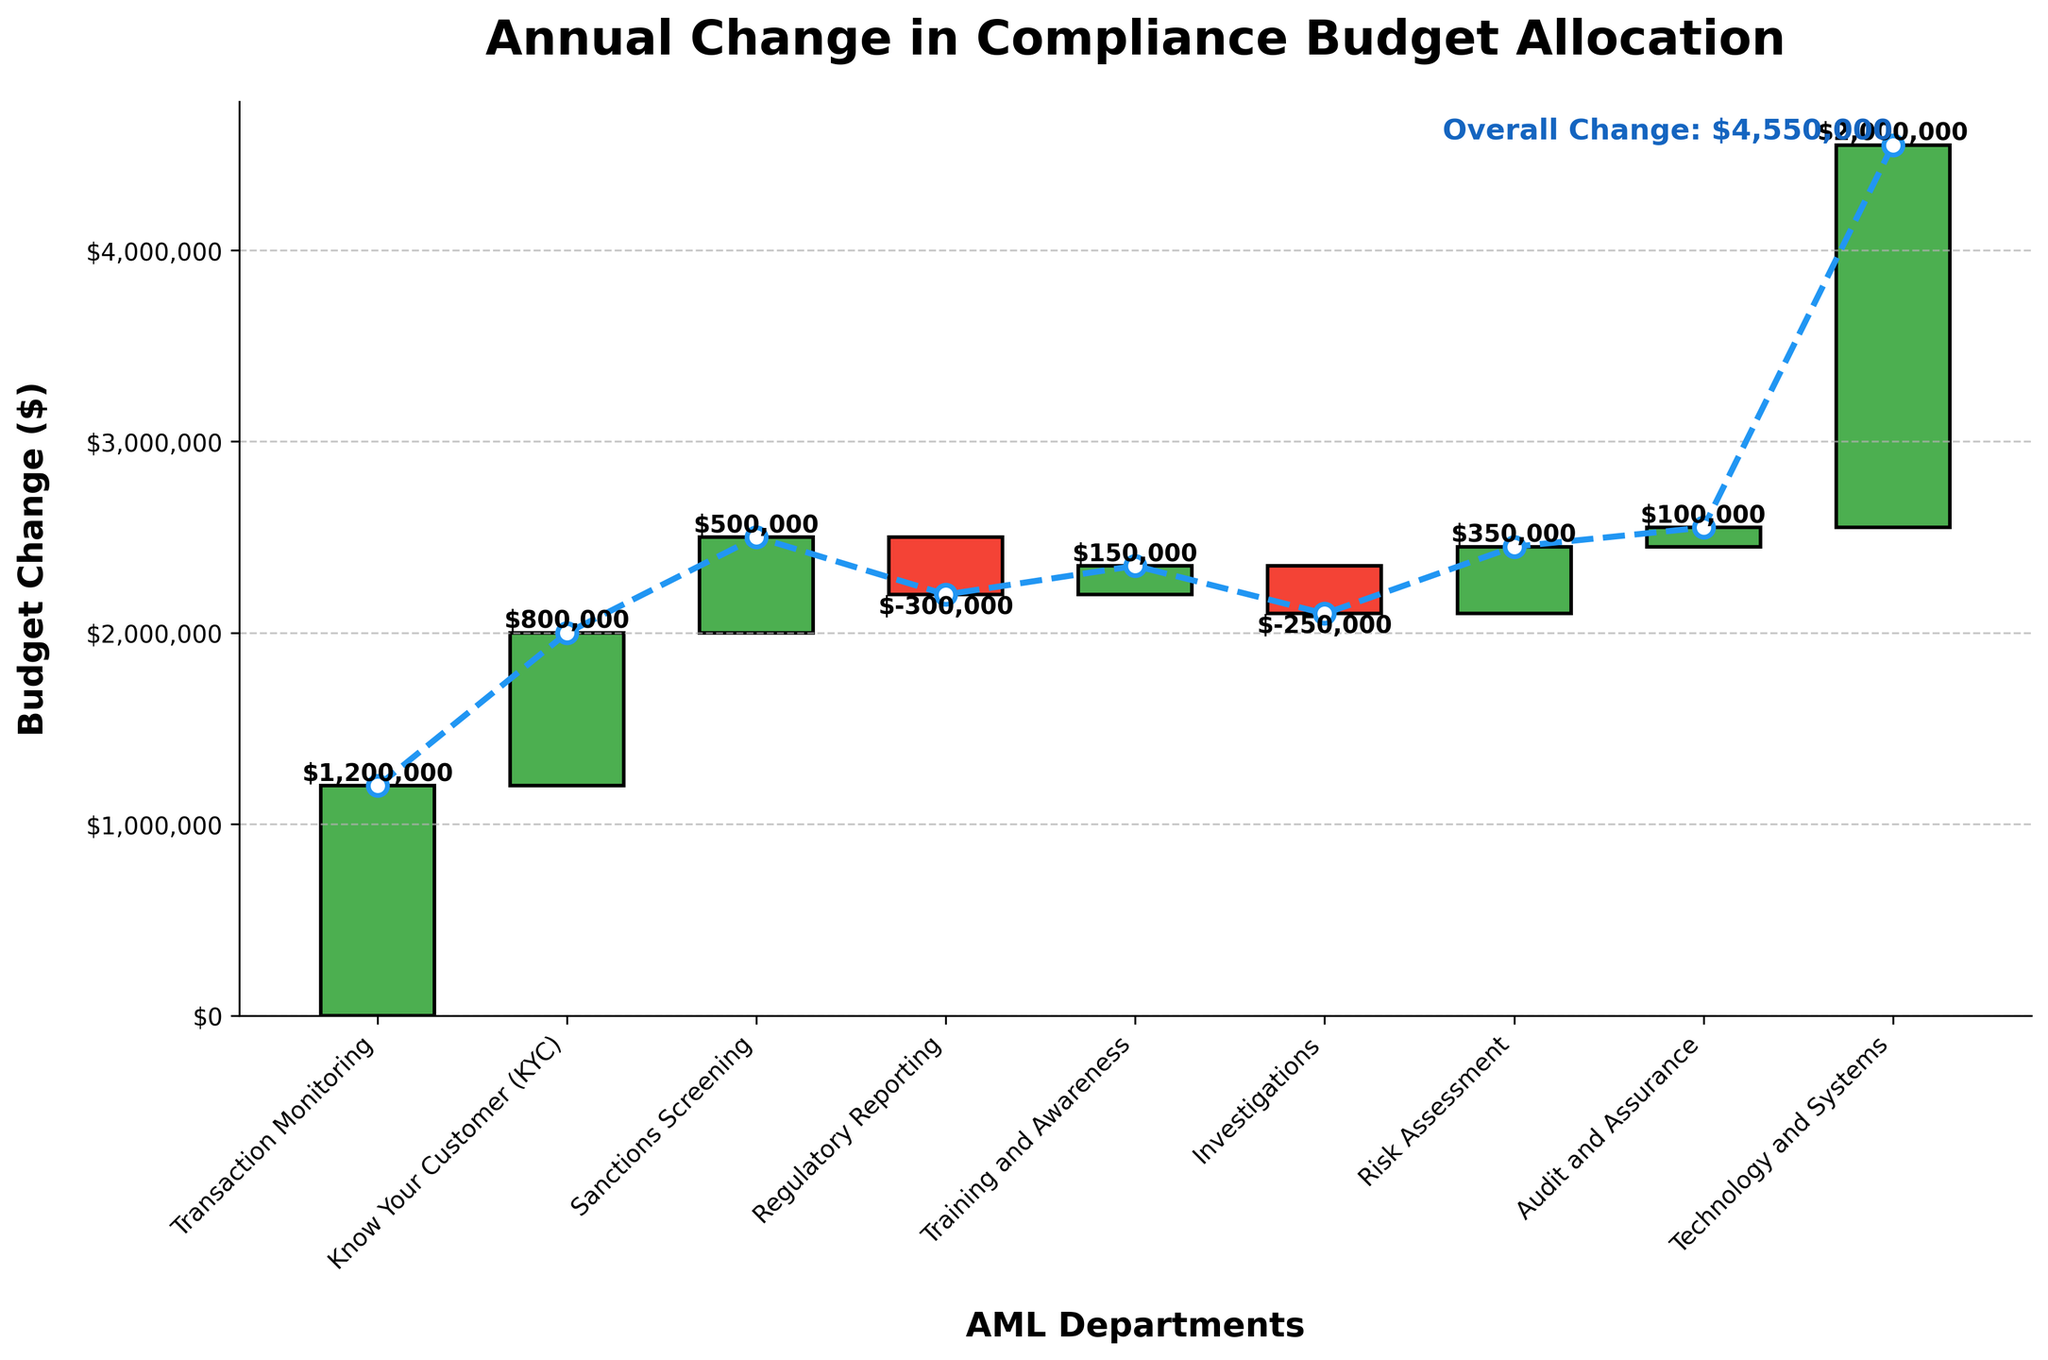How much was the overall change in the budget? The overall change is provided at the end of the chart, highlighted in blue text. The text indicates "Overall Change: $4,550,000."
Answer: $4,550,000 Which department had the highest increase in budget allocation? By looking at the bars, the department with the tallest green bar has the highest increase. The "Technology and Systems" department has the highest increase of $2,000,000.
Answer: Technology and Systems Which department had the largest decrease in budget allocation? The department with the longest red bar indicates the largest decrease. The "Regulatory Reporting" department has the largest decrease of $300,000.
Answer: Regulatory Reporting How much did the "Transaction Monitoring" department's budget change? The "Transaction Monitoring" department's bar shows a budget change of $1,200,000, indicated by the green bar and the text label on top of the bar.
Answer: $1,200,000 Which departments have a negative budget change? Negative budget changes are indicated by the red bars. The departments "Regulatory Reporting" and "Investigations" have a negative budget change.
Answer: Regulatory Reporting and Investigations What is the cumulative budget change just before the "Audit and Assurance" department's bar? The bar before "Audit and Assurance" is "Risk Assessment." The cumulative budget change is the sum of previous changes up to this point. Referring to the bars: 
  1,200,000 (Transaction Monitoring) 
+ 800,000 (Know Your Customer)
+ 500,000 (Sanctions Screening)
- 300,000 (Regulatory Reporting)
+ 150,000 (Training and Awareness)
- 250,000 (Investigations)
+ 350,000 (Risk Assessment)
= $2,450,000.
The cumulative budget change before "Audit and Assurance" is $2,450,000.
Answer: $2,450,000 Which department lies midway in terms of changes between the highest increase and the largest decrease? To find the midpoint in changes, one needs to consider both the highest increase and the largest decrease and find a department whose change is halfway between the two values. The highest increase is "Technology and Systems" with $2,000,000 and the largest decrease is "Regulatory Reporting" with -$300,000. The midway point between these two values might be subjective based on other departments' values closely aligning between this range:
(2,000,000 to -300,000) => An approximate midpoint increase/decrease close to average. "Risk Assessment" department with a change of +$350,000 seems to act as a reasonable midpoint.
Answer: Risk Assessment What is the total combined change for all departments with a positive change? Add the changes of all departments with a positive change:
1,200,000 (Transaction Monitoring) 
+ 800,000 (Know Your Customer)
+ 500,000 (Sanctions Screening)
+ 150,000 (Training and Awareness)
+ 350,000 (Risk Assessment)
+ 100,000 (Audit and Assurance) 
+ 2,000,000 (Technology and Systems) 
= $5,100,000.
The total combined change for all departments with a positive change is $5,100,000.
Answer: $5,100,000 